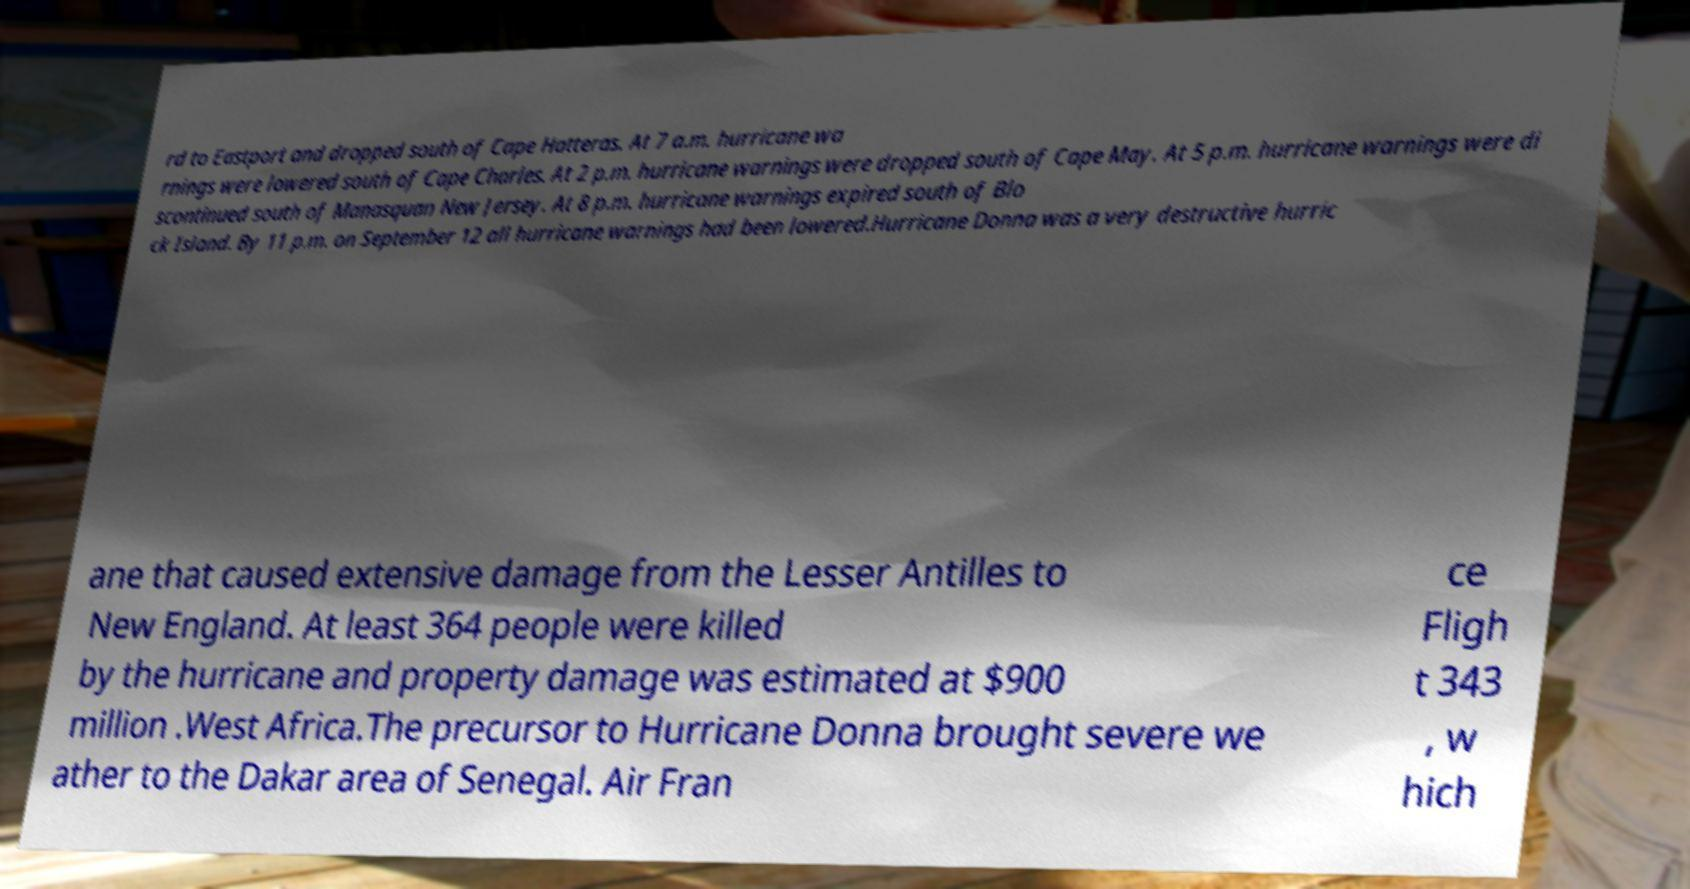Can you accurately transcribe the text from the provided image for me? rd to Eastport and dropped south of Cape Hatteras. At 7 a.m. hurricane wa rnings were lowered south of Cape Charles. At 2 p.m. hurricane warnings were dropped south of Cape May. At 5 p.m. hurricane warnings were di scontinued south of Manasquan New Jersey. At 8 p.m. hurricane warnings expired south of Blo ck Island. By 11 p.m. on September 12 all hurricane warnings had been lowered.Hurricane Donna was a very destructive hurric ane that caused extensive damage from the Lesser Antilles to New England. At least 364 people were killed by the hurricane and property damage was estimated at $900 million .West Africa.The precursor to Hurricane Donna brought severe we ather to the Dakar area of Senegal. Air Fran ce Fligh t 343 , w hich 